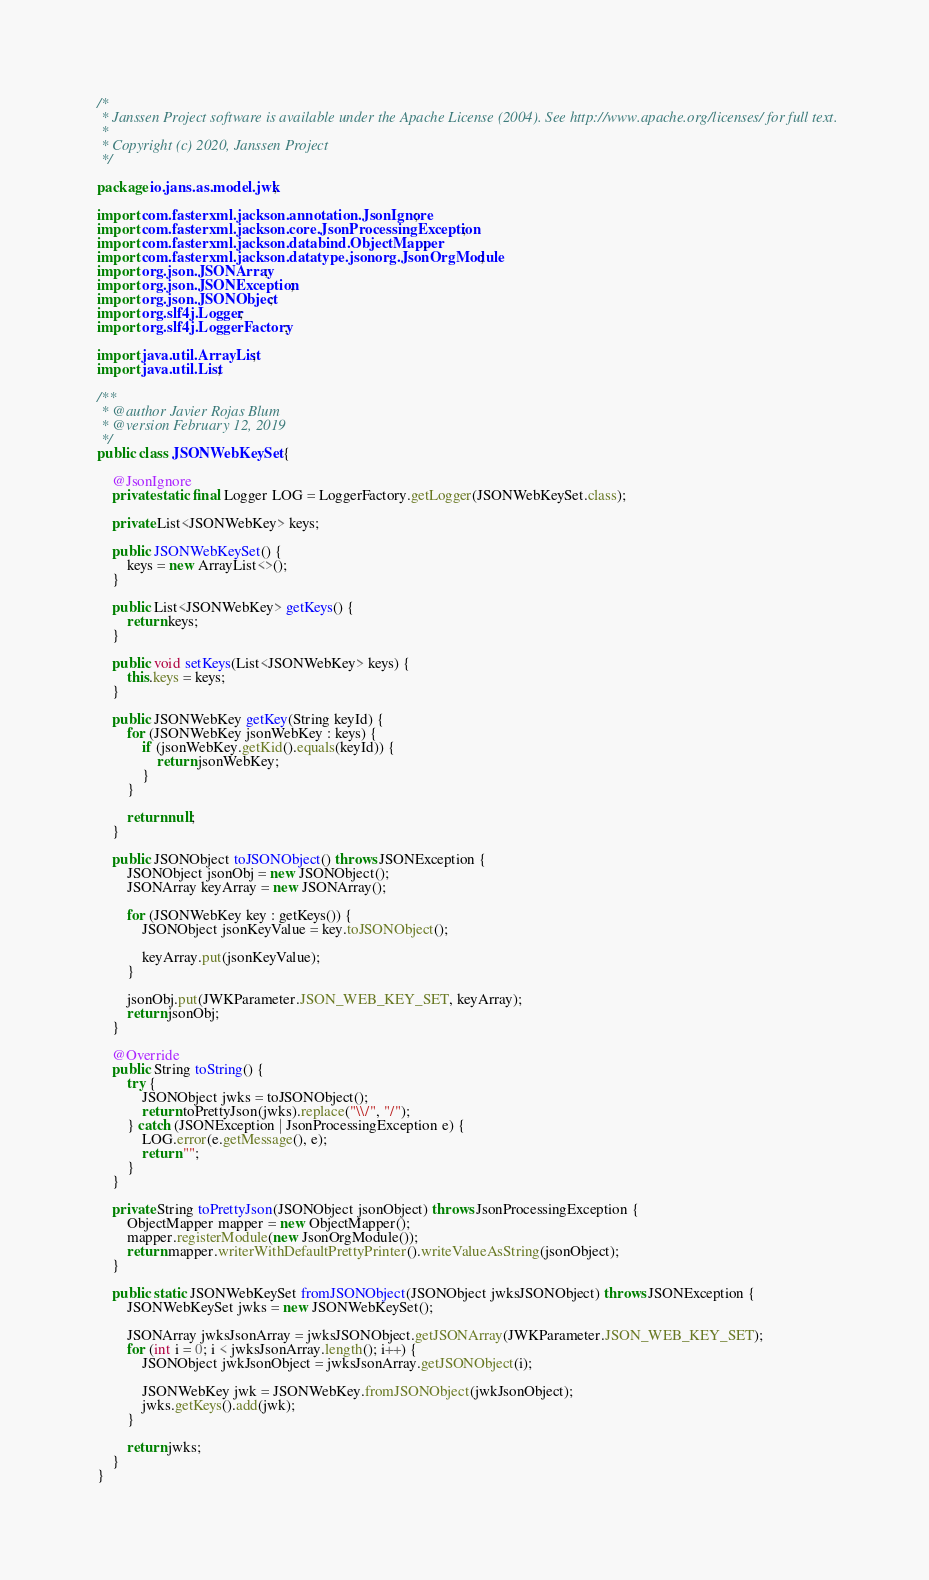<code> <loc_0><loc_0><loc_500><loc_500><_Java_>/*
 * Janssen Project software is available under the Apache License (2004). See http://www.apache.org/licenses/ for full text.
 *
 * Copyright (c) 2020, Janssen Project
 */

package io.jans.as.model.jwk;

import com.fasterxml.jackson.annotation.JsonIgnore;
import com.fasterxml.jackson.core.JsonProcessingException;
import com.fasterxml.jackson.databind.ObjectMapper;
import com.fasterxml.jackson.datatype.jsonorg.JsonOrgModule;
import org.json.JSONArray;
import org.json.JSONException;
import org.json.JSONObject;
import org.slf4j.Logger;
import org.slf4j.LoggerFactory;

import java.util.ArrayList;
import java.util.List;

/**
 * @author Javier Rojas Blum
 * @version February 12, 2019
 */
public class JSONWebKeySet {

    @JsonIgnore
    private static final Logger LOG = LoggerFactory.getLogger(JSONWebKeySet.class);

    private List<JSONWebKey> keys;

    public JSONWebKeySet() {
        keys = new ArrayList<>();
    }

    public List<JSONWebKey> getKeys() {
        return keys;
    }

    public void setKeys(List<JSONWebKey> keys) {
        this.keys = keys;
    }

    public JSONWebKey getKey(String keyId) {
        for (JSONWebKey jsonWebKey : keys) {
            if (jsonWebKey.getKid().equals(keyId)) {
                return jsonWebKey;
            }
        }

        return null;
    }

    public JSONObject toJSONObject() throws JSONException {
        JSONObject jsonObj = new JSONObject();
        JSONArray keyArray = new JSONArray();

        for (JSONWebKey key : getKeys()) {
            JSONObject jsonKeyValue = key.toJSONObject();

            keyArray.put(jsonKeyValue);
        }

        jsonObj.put(JWKParameter.JSON_WEB_KEY_SET, keyArray);
        return jsonObj;
    }

    @Override
    public String toString() {
        try {
            JSONObject jwks = toJSONObject();
            return toPrettyJson(jwks).replace("\\/", "/");
        } catch (JSONException | JsonProcessingException e) {
            LOG.error(e.getMessage(), e);
            return "";
        }
    }

    private String toPrettyJson(JSONObject jsonObject) throws JsonProcessingException {
        ObjectMapper mapper = new ObjectMapper();
        mapper.registerModule(new JsonOrgModule());
        return mapper.writerWithDefaultPrettyPrinter().writeValueAsString(jsonObject);
    }

    public static JSONWebKeySet fromJSONObject(JSONObject jwksJSONObject) throws JSONException {
        JSONWebKeySet jwks = new JSONWebKeySet();

        JSONArray jwksJsonArray = jwksJSONObject.getJSONArray(JWKParameter.JSON_WEB_KEY_SET);
        for (int i = 0; i < jwksJsonArray.length(); i++) {
            JSONObject jwkJsonObject = jwksJsonArray.getJSONObject(i);

            JSONWebKey jwk = JSONWebKey.fromJSONObject(jwkJsonObject);
            jwks.getKeys().add(jwk);
        }

        return jwks;
    }
}</code> 